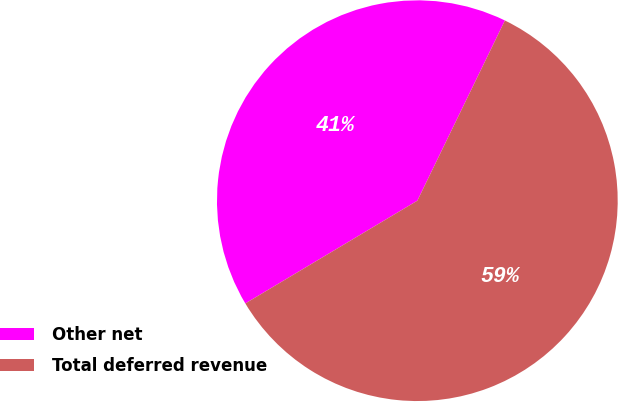Convert chart. <chart><loc_0><loc_0><loc_500><loc_500><pie_chart><fcel>Other net<fcel>Total deferred revenue<nl><fcel>40.77%<fcel>59.23%<nl></chart> 